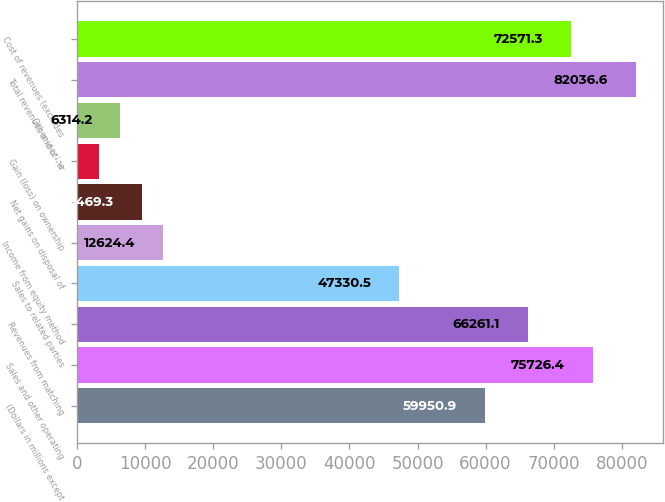Convert chart to OTSL. <chart><loc_0><loc_0><loc_500><loc_500><bar_chart><fcel>(Dollars in millions except<fcel>Sales and other operating<fcel>Revenues from matching<fcel>Sales to related parties<fcel>Income from equity method<fcel>Net gains on disposal of<fcel>Gain (loss) on ownership<fcel>Other income<fcel>Total revenues and other<fcel>Cost of revenues (excludes<nl><fcel>59950.9<fcel>75726.4<fcel>66261.1<fcel>47330.5<fcel>12624.4<fcel>9469.3<fcel>3159.1<fcel>6314.2<fcel>82036.6<fcel>72571.3<nl></chart> 